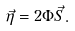<formula> <loc_0><loc_0><loc_500><loc_500>\vec { \eta } = 2 \Phi \vec { S } .</formula> 